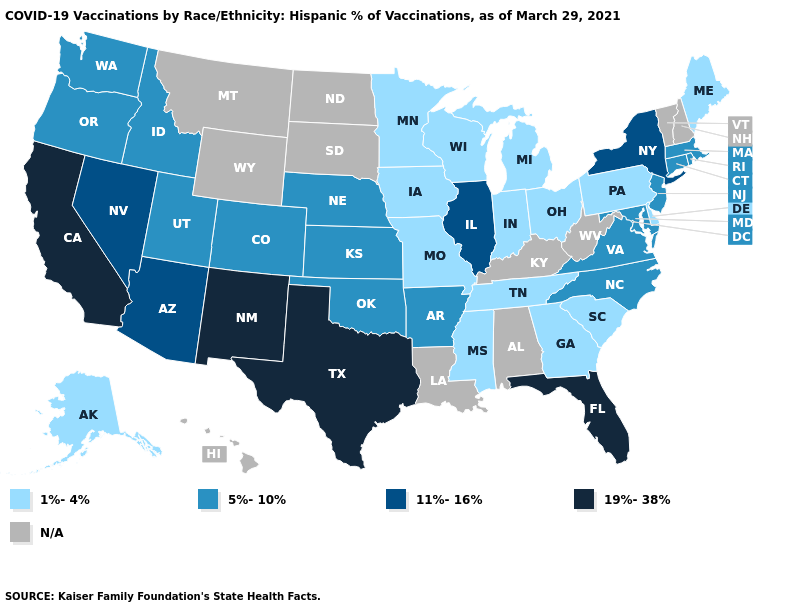What is the value of New Hampshire?
Write a very short answer. N/A. What is the highest value in the Northeast ?
Concise answer only. 11%-16%. What is the highest value in the USA?
Quick response, please. 19%-38%. What is the highest value in states that border Virginia?
Short answer required. 5%-10%. What is the value of New Mexico?
Give a very brief answer. 19%-38%. Among the states that border Minnesota , which have the highest value?
Answer briefly. Iowa, Wisconsin. Does the map have missing data?
Concise answer only. Yes. Name the states that have a value in the range 19%-38%?
Quick response, please. California, Florida, New Mexico, Texas. Among the states that border New York , which have the highest value?
Concise answer only. Connecticut, Massachusetts, New Jersey. What is the value of New Jersey?
Keep it brief. 5%-10%. Does South Carolina have the lowest value in the USA?
Concise answer only. Yes. How many symbols are there in the legend?
Be succinct. 5. Does the map have missing data?
Quick response, please. Yes. Name the states that have a value in the range N/A?
Give a very brief answer. Alabama, Hawaii, Kentucky, Louisiana, Montana, New Hampshire, North Dakota, South Dakota, Vermont, West Virginia, Wyoming. 